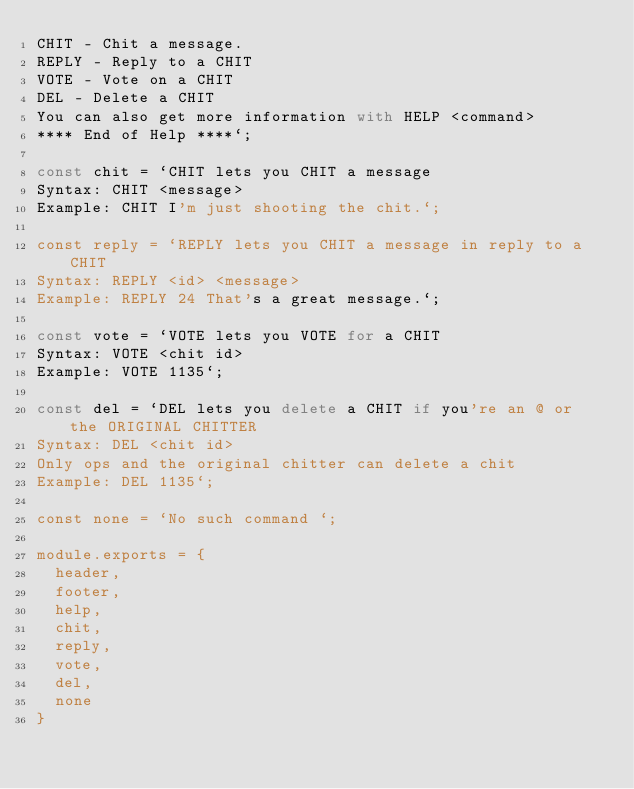<code> <loc_0><loc_0><loc_500><loc_500><_JavaScript_>CHIT - Chit a message.
REPLY - Reply to a CHIT
VOTE - Vote on a CHIT
DEL - Delete a CHIT
You can also get more information with HELP <command>
**** End of Help ****`;

const chit = `CHIT lets you CHIT a message
Syntax: CHIT <message>
Example: CHIT I'm just shooting the chit.`;

const reply = `REPLY lets you CHIT a message in reply to a CHIT
Syntax: REPLY <id> <message>
Example: REPLY 24 That's a great message.`;

const vote = `VOTE lets you VOTE for a CHIT
Syntax: VOTE <chit id>
Example: VOTE 1135`;

const del = `DEL lets you delete a CHIT if you're an @ or the ORIGINAL CHITTER
Syntax: DEL <chit id>
Only ops and the original chitter can delete a chit
Example: DEL 1135`;

const none = `No such command `;

module.exports = {
  header,
  footer,
  help,
  chit,
  reply,
  vote,
  del,
  none
}
</code> 